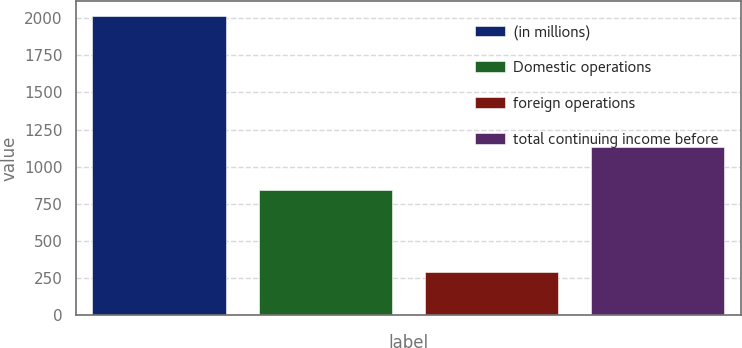Convert chart to OTSL. <chart><loc_0><loc_0><loc_500><loc_500><bar_chart><fcel>(in millions)<fcel>Domestic operations<fcel>foreign operations<fcel>total continuing income before<nl><fcel>2012<fcel>841<fcel>289<fcel>1130<nl></chart> 